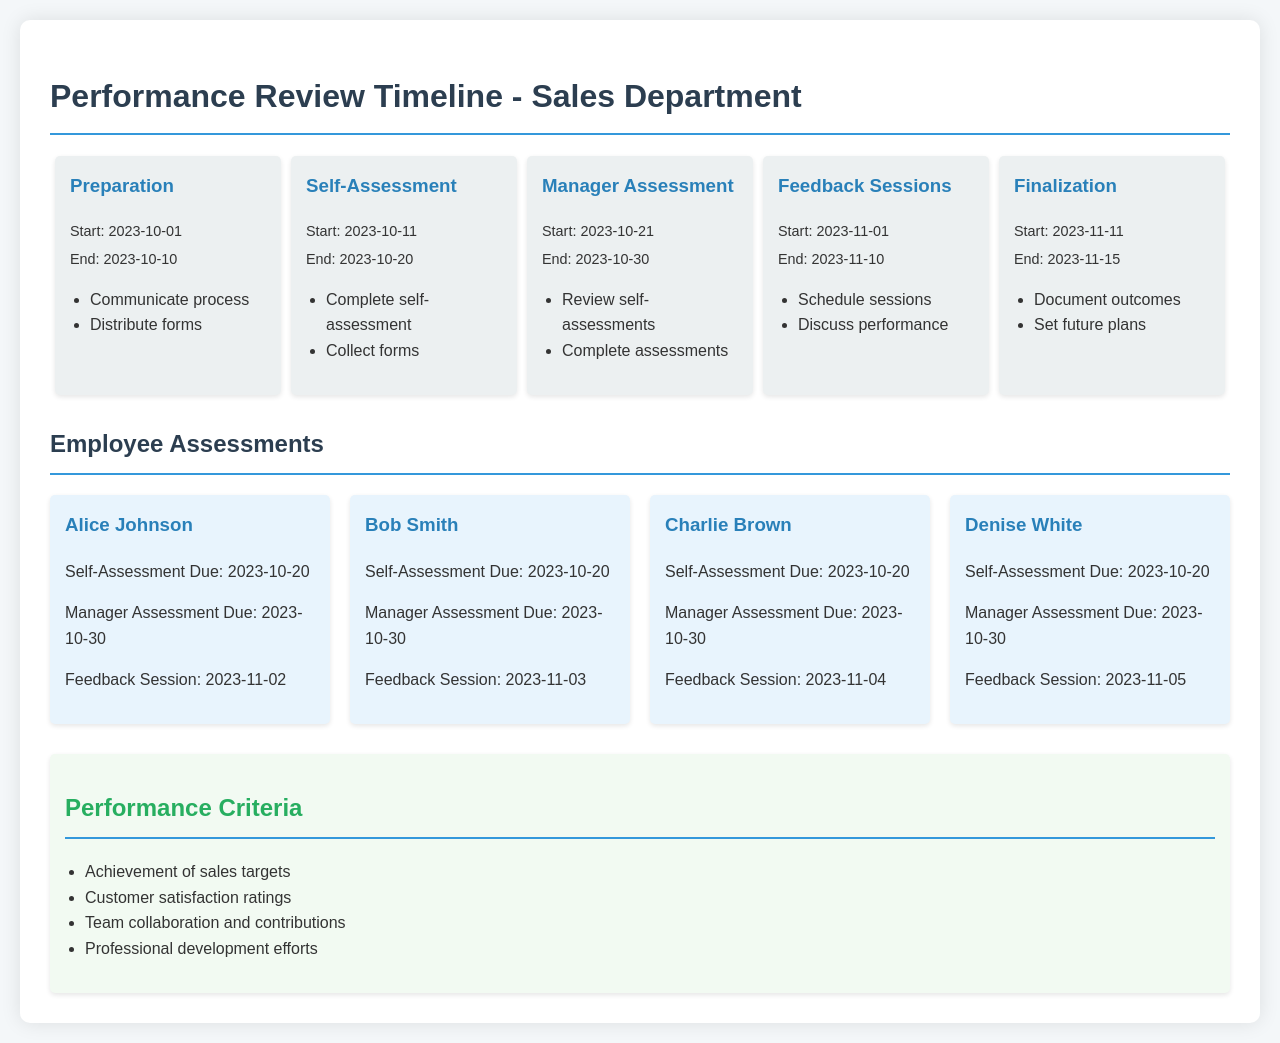What is the start date of the Self-Assessment phase? The Self-Assessment phase starts on 2023-10-11 according to the timeline.
Answer: 2023-10-11 When is the feedback session for Bob Smith? Bob Smith's feedback session is scheduled for 2023-11-03 as per his employee card.
Answer: 2023-11-03 What are the performance criteria to be assessed? The performance criteria include achievement of sales targets, customer satisfaction ratings, team collaboration, and professional development efforts.
Answer: Achievement of sales targets, customer satisfaction ratings, team collaboration, professional development efforts What is the end date of the Manager Assessment phase? The Manager Assessment phase ends on 2023-10-30 according to the timeline provided.
Answer: 2023-10-30 How many employees have their Self-Assessments due on the same date? Four employees (Alice Johnson, Bob Smith, Charlie Brown, and Denise White) have their Self-Assessments due on 2023-10-20.
Answer: Four What is the total duration of the Performance Review Timeline? The entire review process spans from preparation starting on 2023-10-01 to finalization ending on 2023-11-15, covering 45 days in total.
Answer: 45 days 